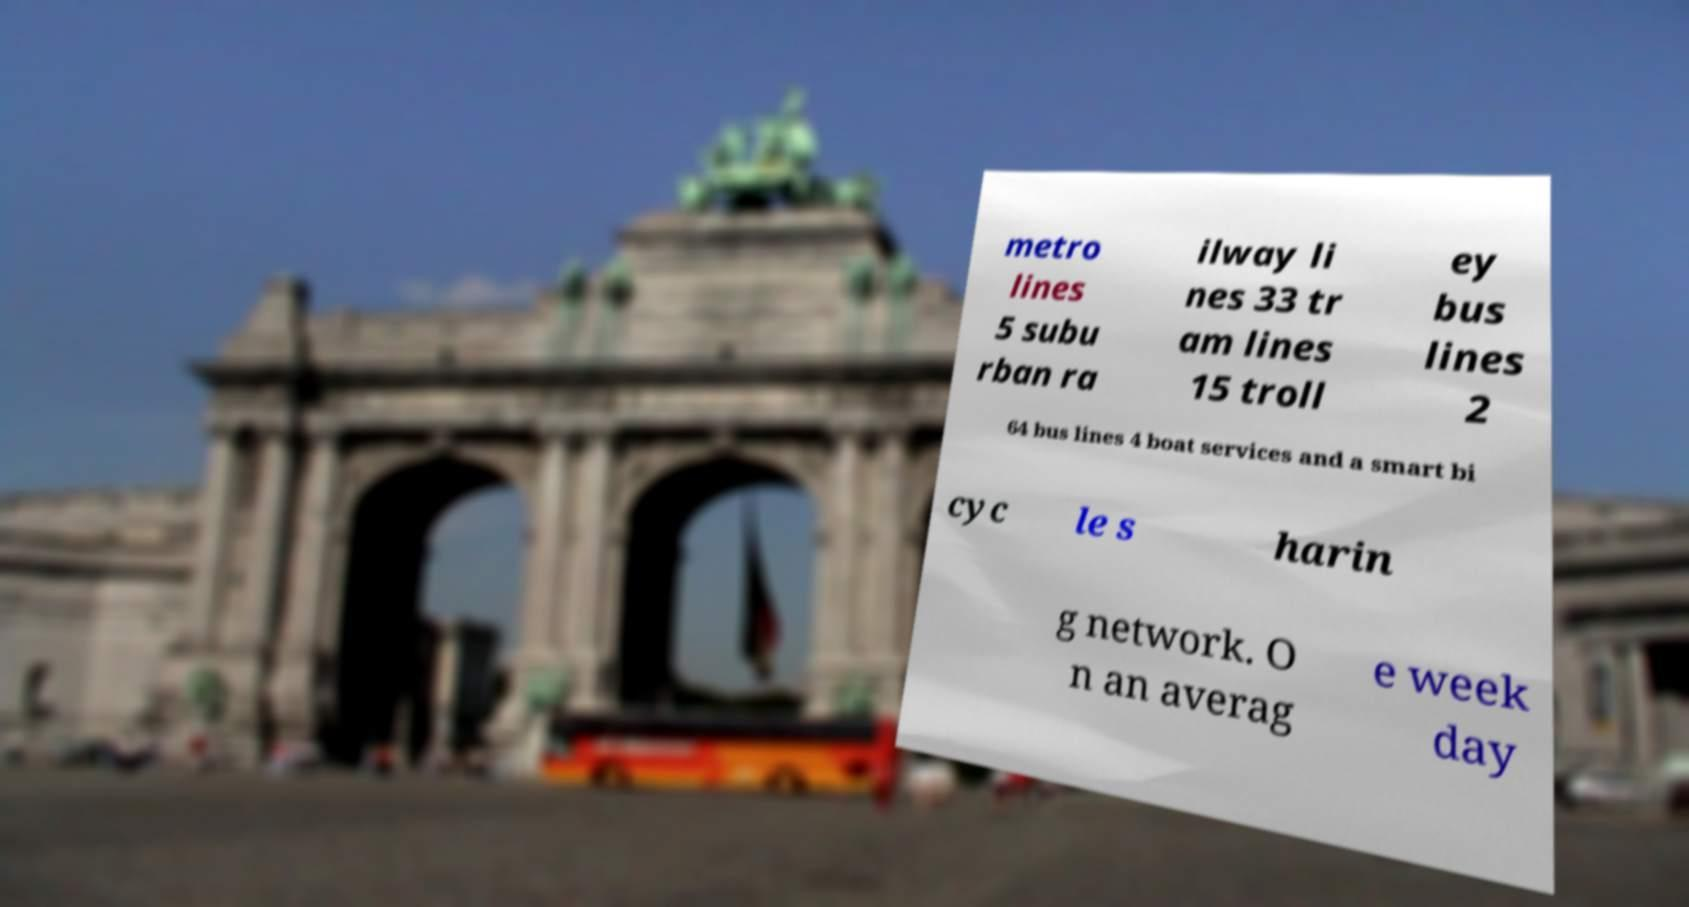Could you extract and type out the text from this image? metro lines 5 subu rban ra ilway li nes 33 tr am lines 15 troll ey bus lines 2 64 bus lines 4 boat services and a smart bi cyc le s harin g network. O n an averag e week day 